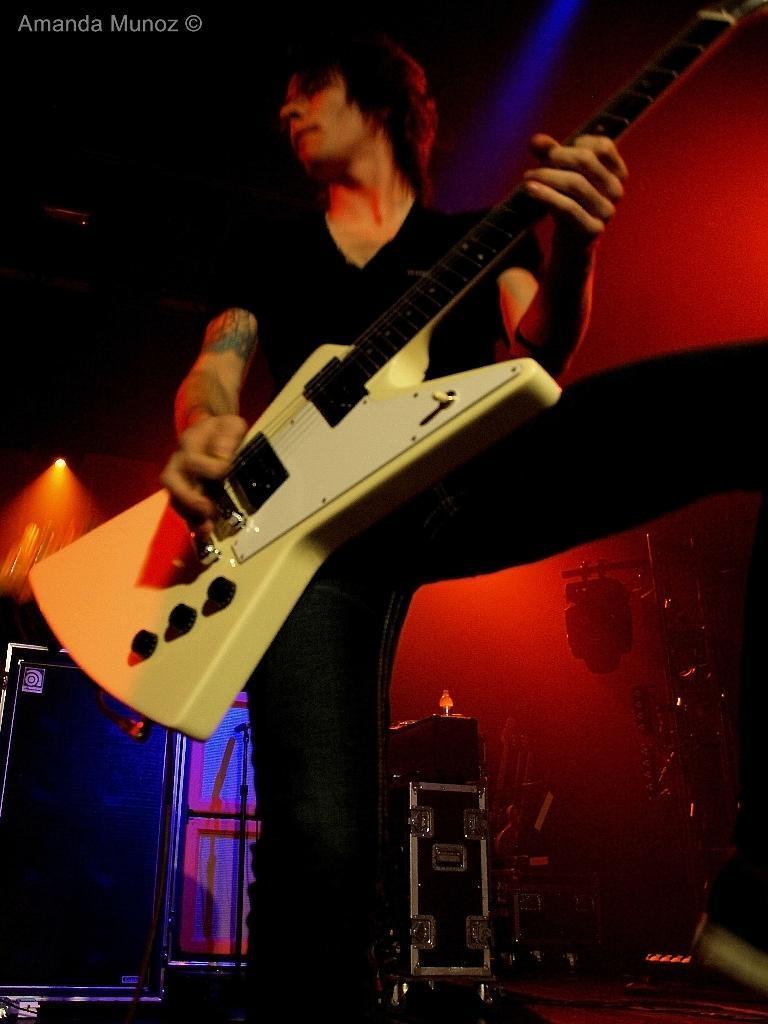How would you summarize this image in a sentence or two? A man is standing also playing the guitar and he wears a black color t-shirt and also a jeans. He is looking at the left. 